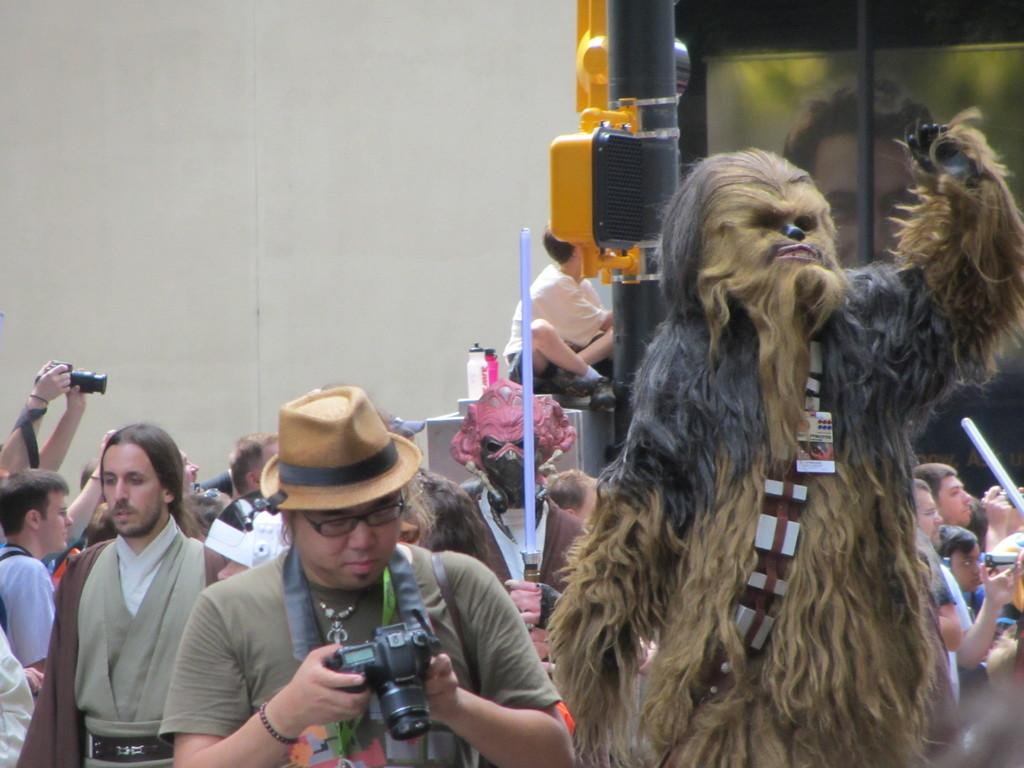What are the people in the image doing? The group of people is standing on the ground in the image. Can you describe any specific objects or accessories in the image? There is a mask visible in the image. What type of structure can be seen in the background? There is a wall in the image. Are there any other objects or features in the image? Yes, there is a pole in the image. What type of bells can be heard ringing in the image? There are no bells present in the image, and therefore no sound can be heard. 